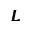Convert formula to latex. <formula><loc_0><loc_0><loc_500><loc_500>\pm b { L }</formula> 